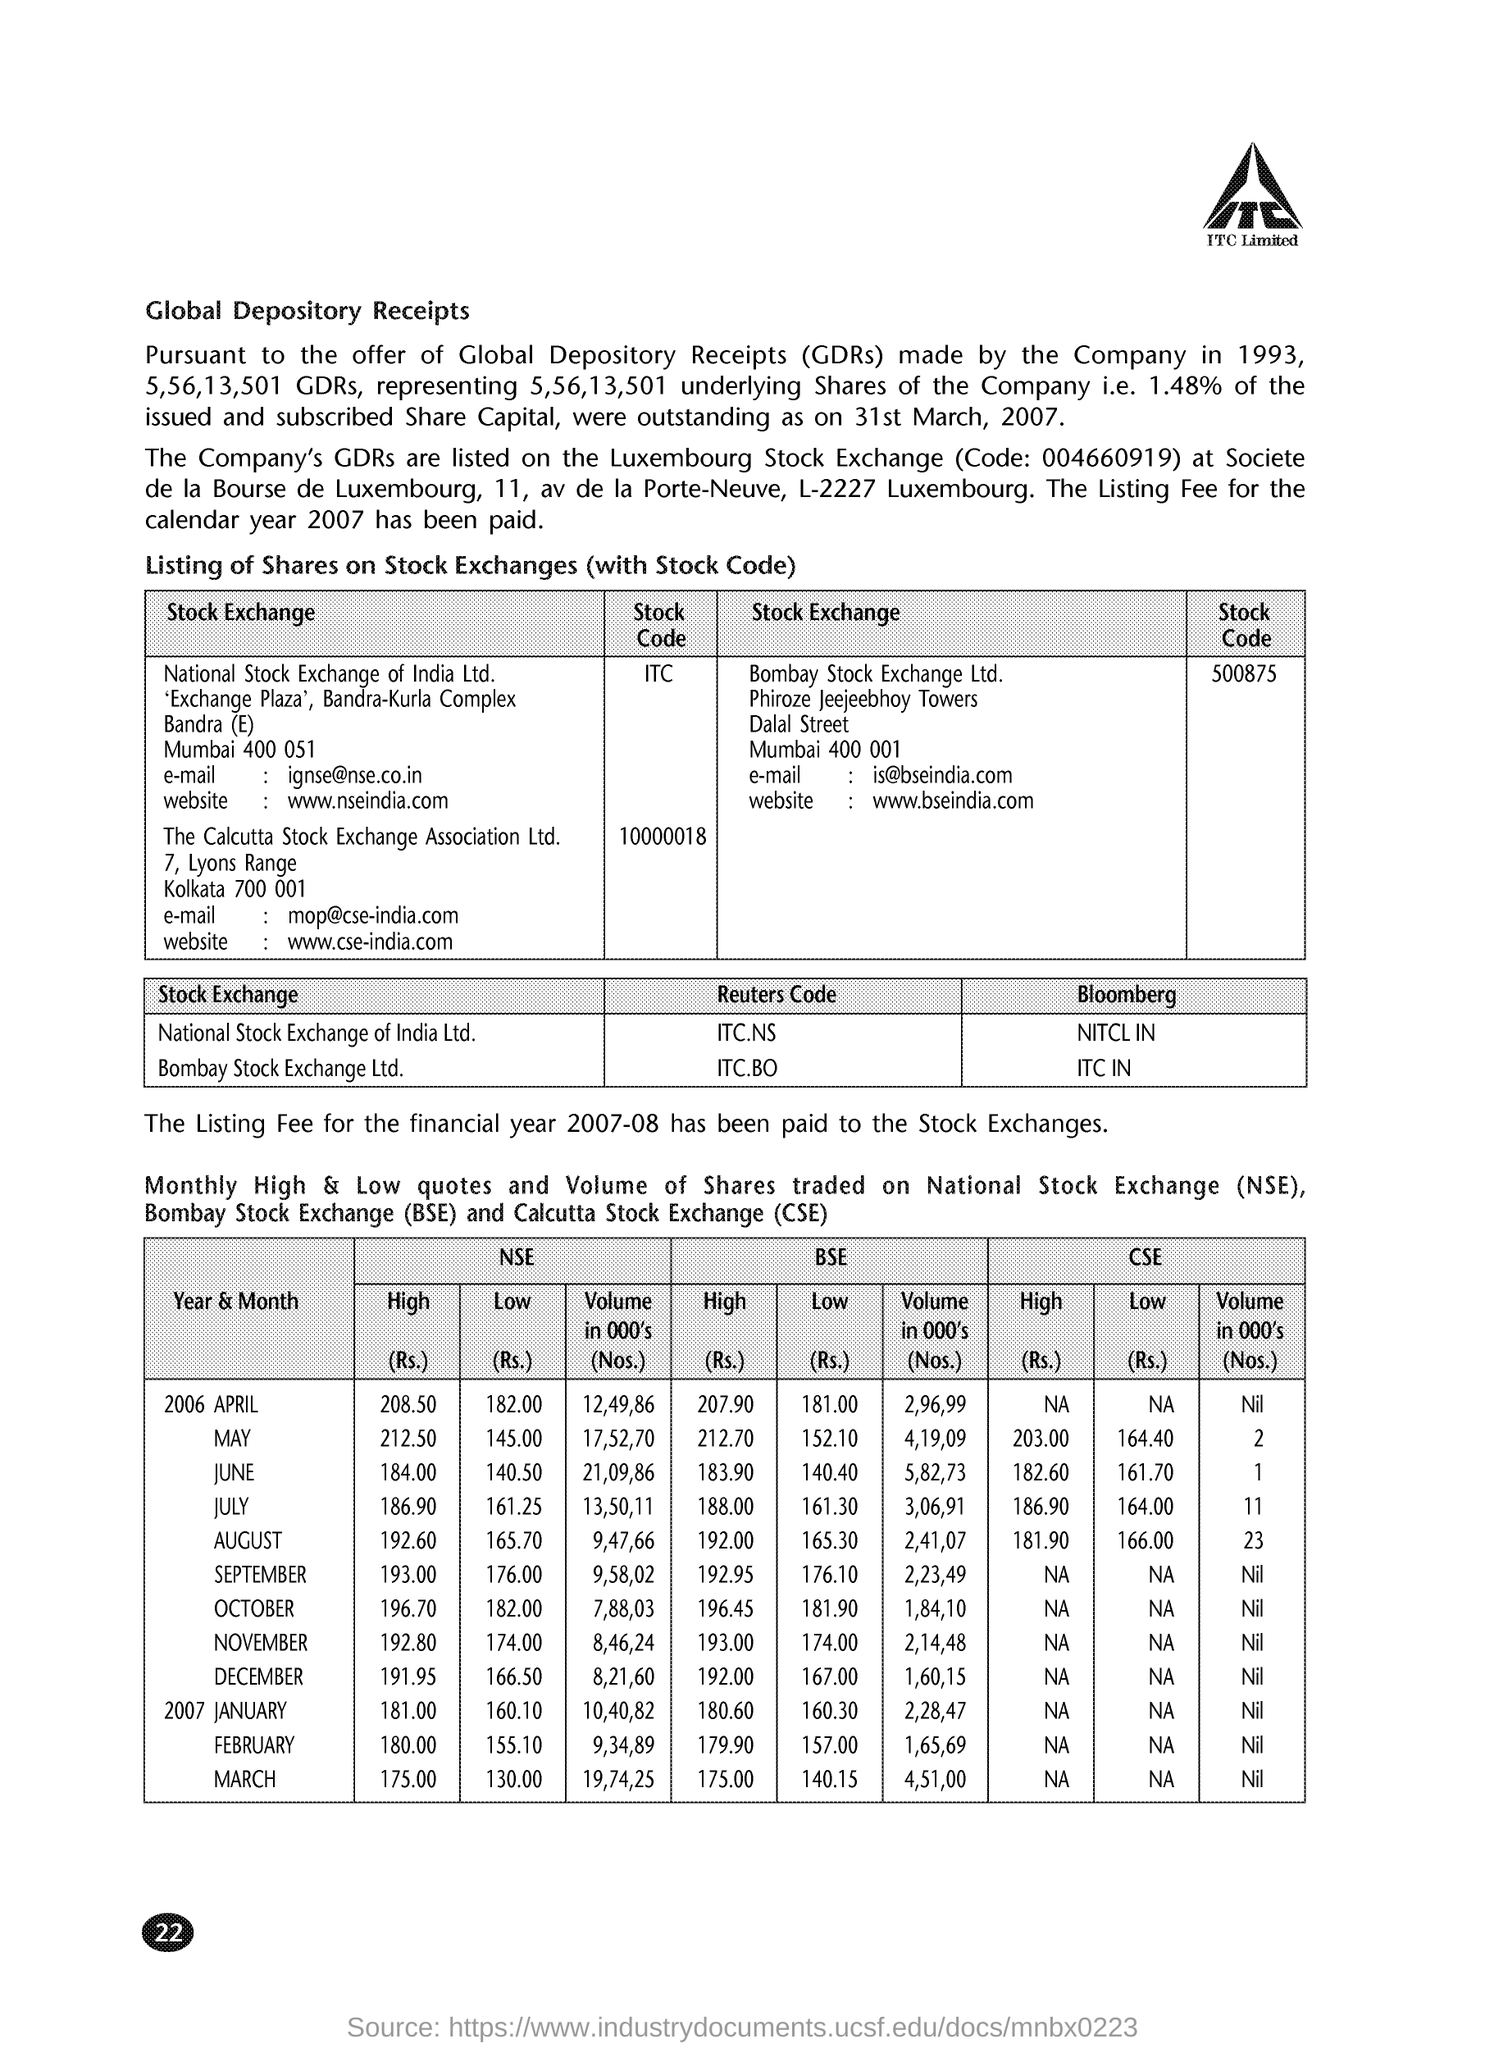In which city national stock exchange of india ltd is located ?
Offer a terse response. MUMBAI. What is the stock code of bombay stock exchange ltd .
Offer a very short reply. 500875. What is the full form of bse ?
Your answer should be compact. Bombay stock exchange. What is the full form of nse ?
Your response must be concise. National Stock exchange. What is the full form of cse ?
Keep it short and to the point. Calcutta stock exchange. What is the high price of nse on april 2006
Your response must be concise. 208.50. What is the high price of cse on  july  2006
Make the answer very short. 186.90. What is the e-mail for calcutta stock exchange association ltd .
Your response must be concise. Mop@cse-india.com. The listing fee for which  financial year has been paid to the stock exchanges
Provide a short and direct response. 2007-08. 